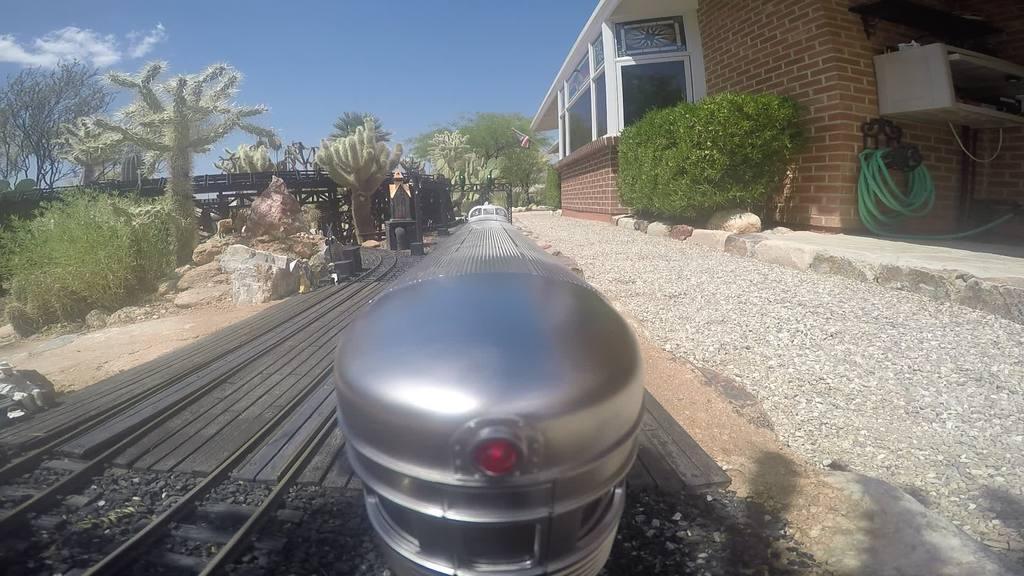Can you describe this image briefly? In this image we can see the building, one flag with pole, one pipe, some objects attached to the wall, one toy train on the track, some small stones near the track, some rocks, one railway track, some objects looks like rods on the ground, some trees, bushes and plants on the ground. At the top there is the sky with clouds. 